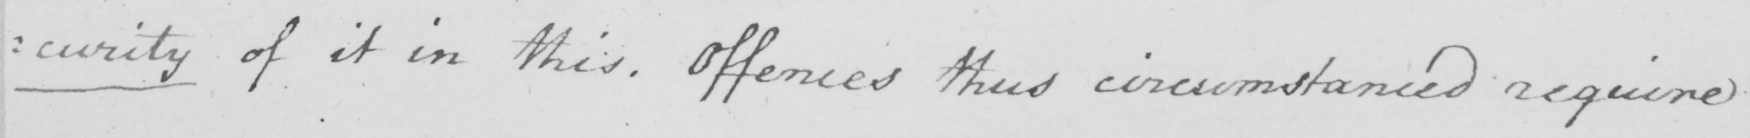Please transcribe the handwritten text in this image. : curity of it in this . Offences thus circumstanced require 